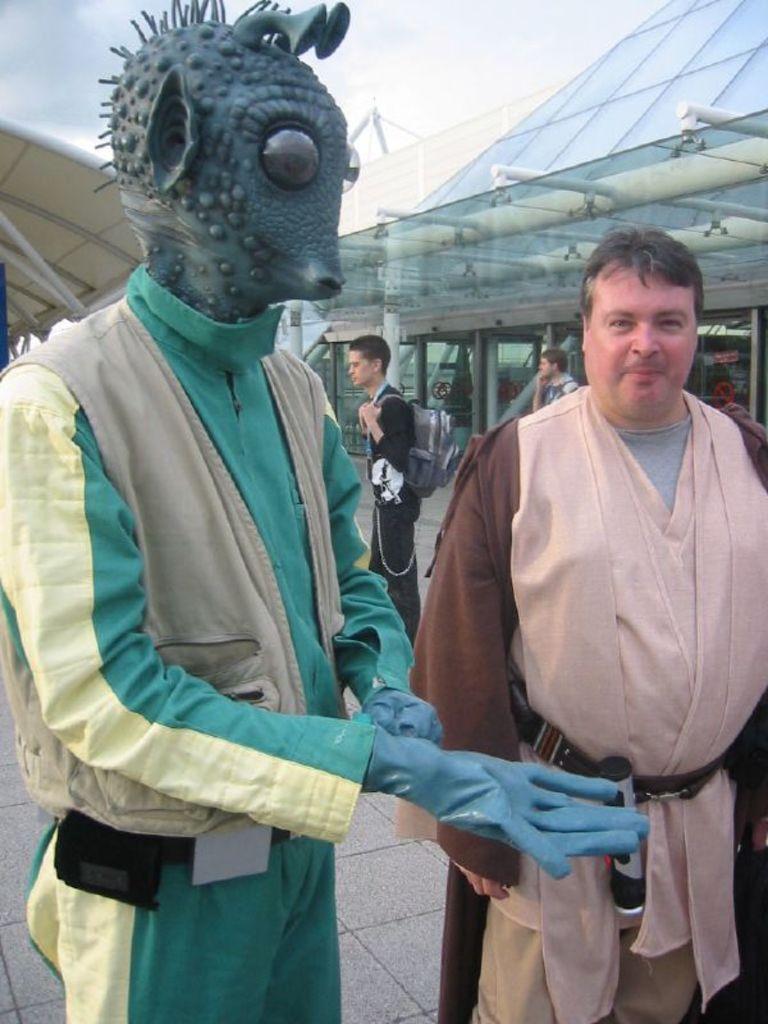Describe this image in one or two sentences. This image is taken outdoors. At the top of the image there is a sky with clouds. On the left side of the image there is a statue. On the right side of the image a man is standing on the floor. In the background a few people are walking on the floor and there are two architectures. 